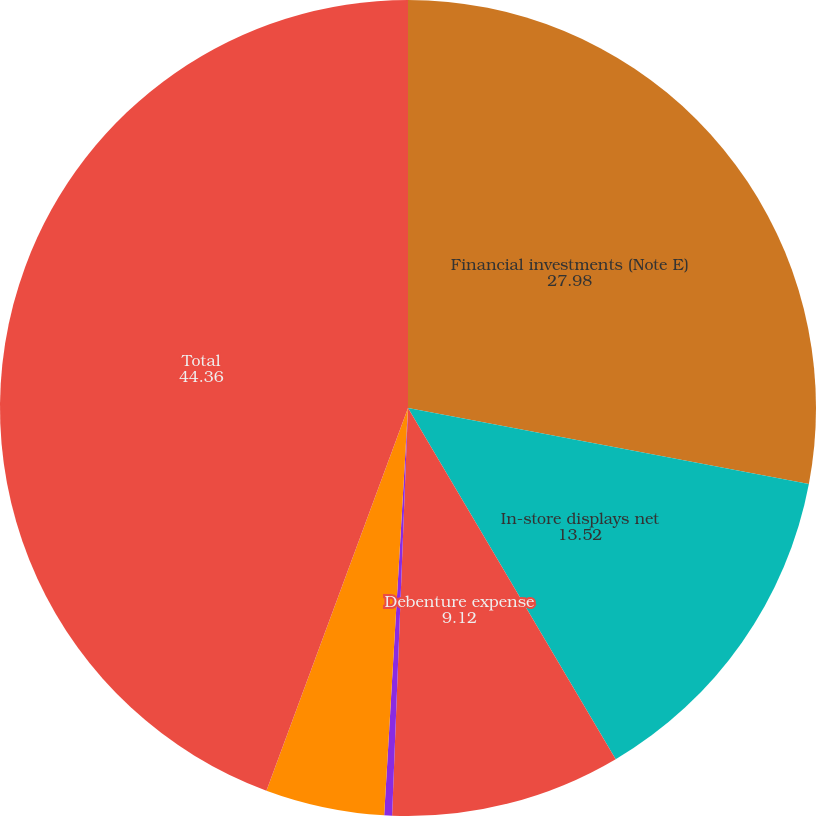Convert chart to OTSL. <chart><loc_0><loc_0><loc_500><loc_500><pie_chart><fcel>Financial investments (Note E)<fcel>In-store displays net<fcel>Debenture expense<fcel>Notes receivable<fcel>Other<fcel>Total<nl><fcel>27.98%<fcel>13.52%<fcel>9.12%<fcel>0.31%<fcel>4.71%<fcel>44.36%<nl></chart> 